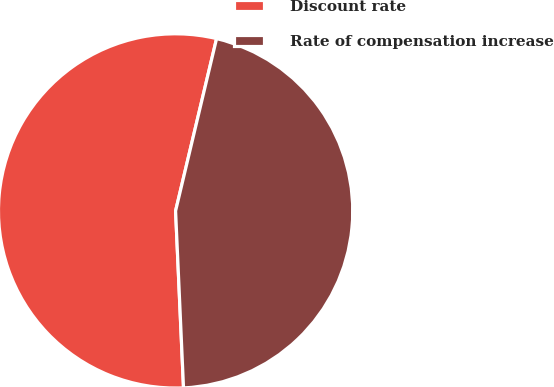Convert chart. <chart><loc_0><loc_0><loc_500><loc_500><pie_chart><fcel>Discount rate<fcel>Rate of compensation increase<nl><fcel>54.43%<fcel>45.57%<nl></chart> 